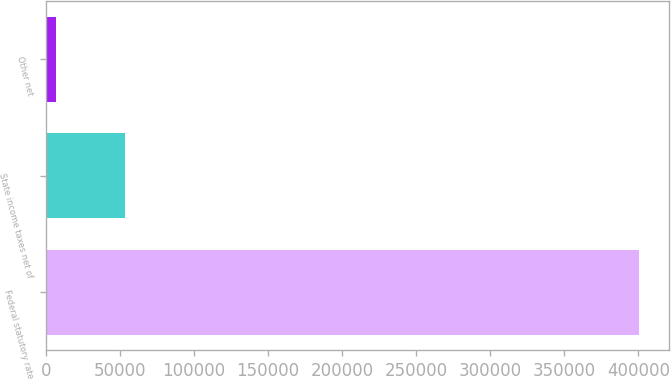<chart> <loc_0><loc_0><loc_500><loc_500><bar_chart><fcel>Federal statutory rate<fcel>State income taxes net of<fcel>Other net<nl><fcel>400547<fcel>53501<fcel>7188<nl></chart> 